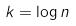Convert formula to latex. <formula><loc_0><loc_0><loc_500><loc_500>k = \log n</formula> 